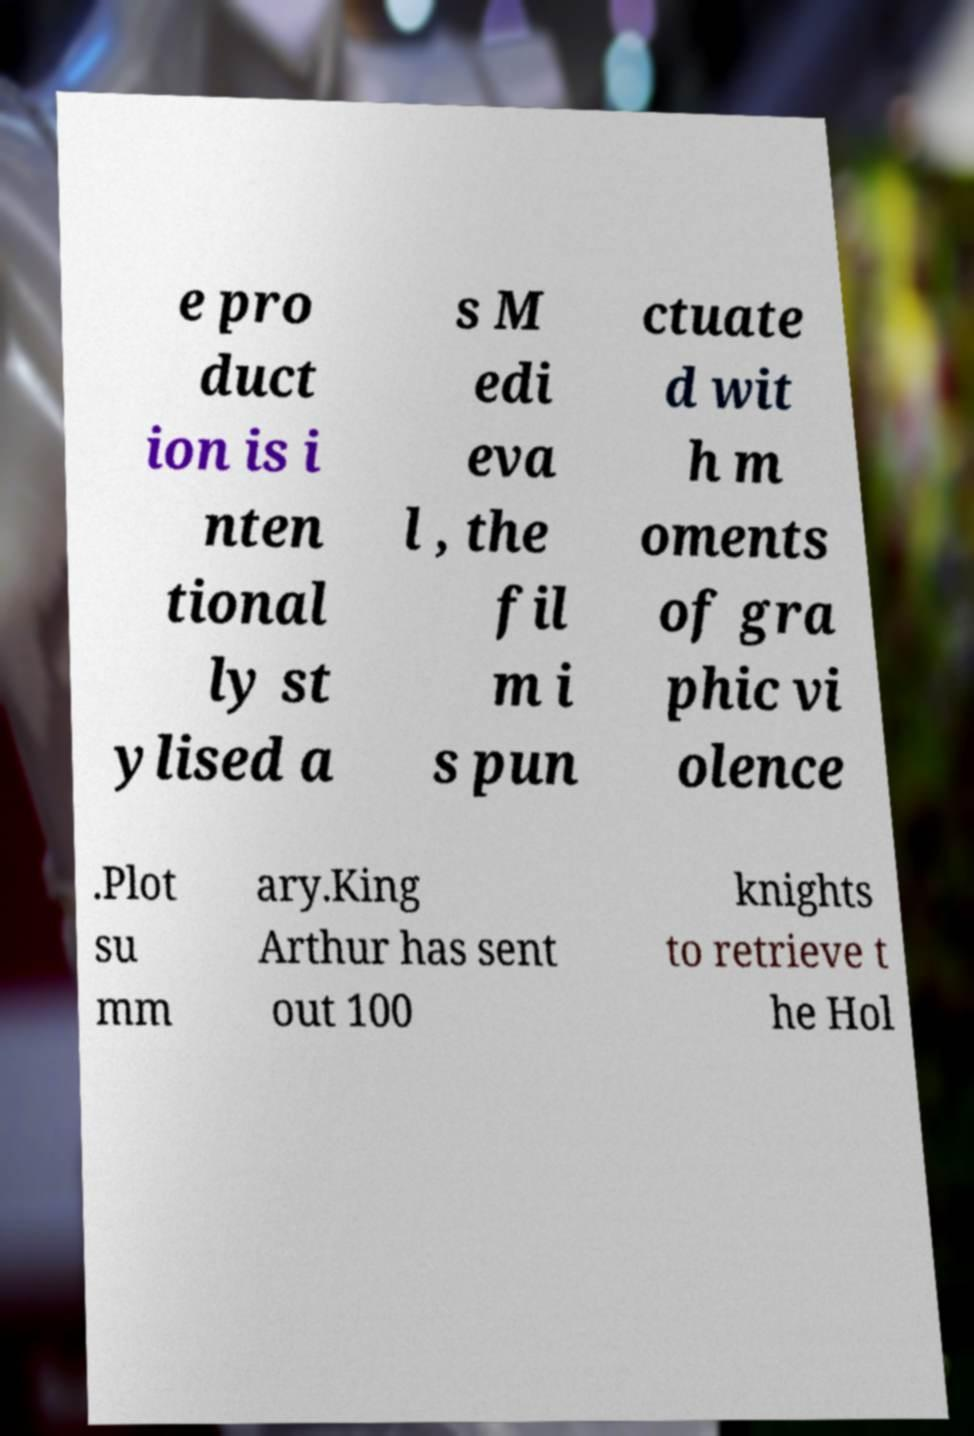I need the written content from this picture converted into text. Can you do that? e pro duct ion is i nten tional ly st ylised a s M edi eva l , the fil m i s pun ctuate d wit h m oments of gra phic vi olence .Plot su mm ary.King Arthur has sent out 100 knights to retrieve t he Hol 